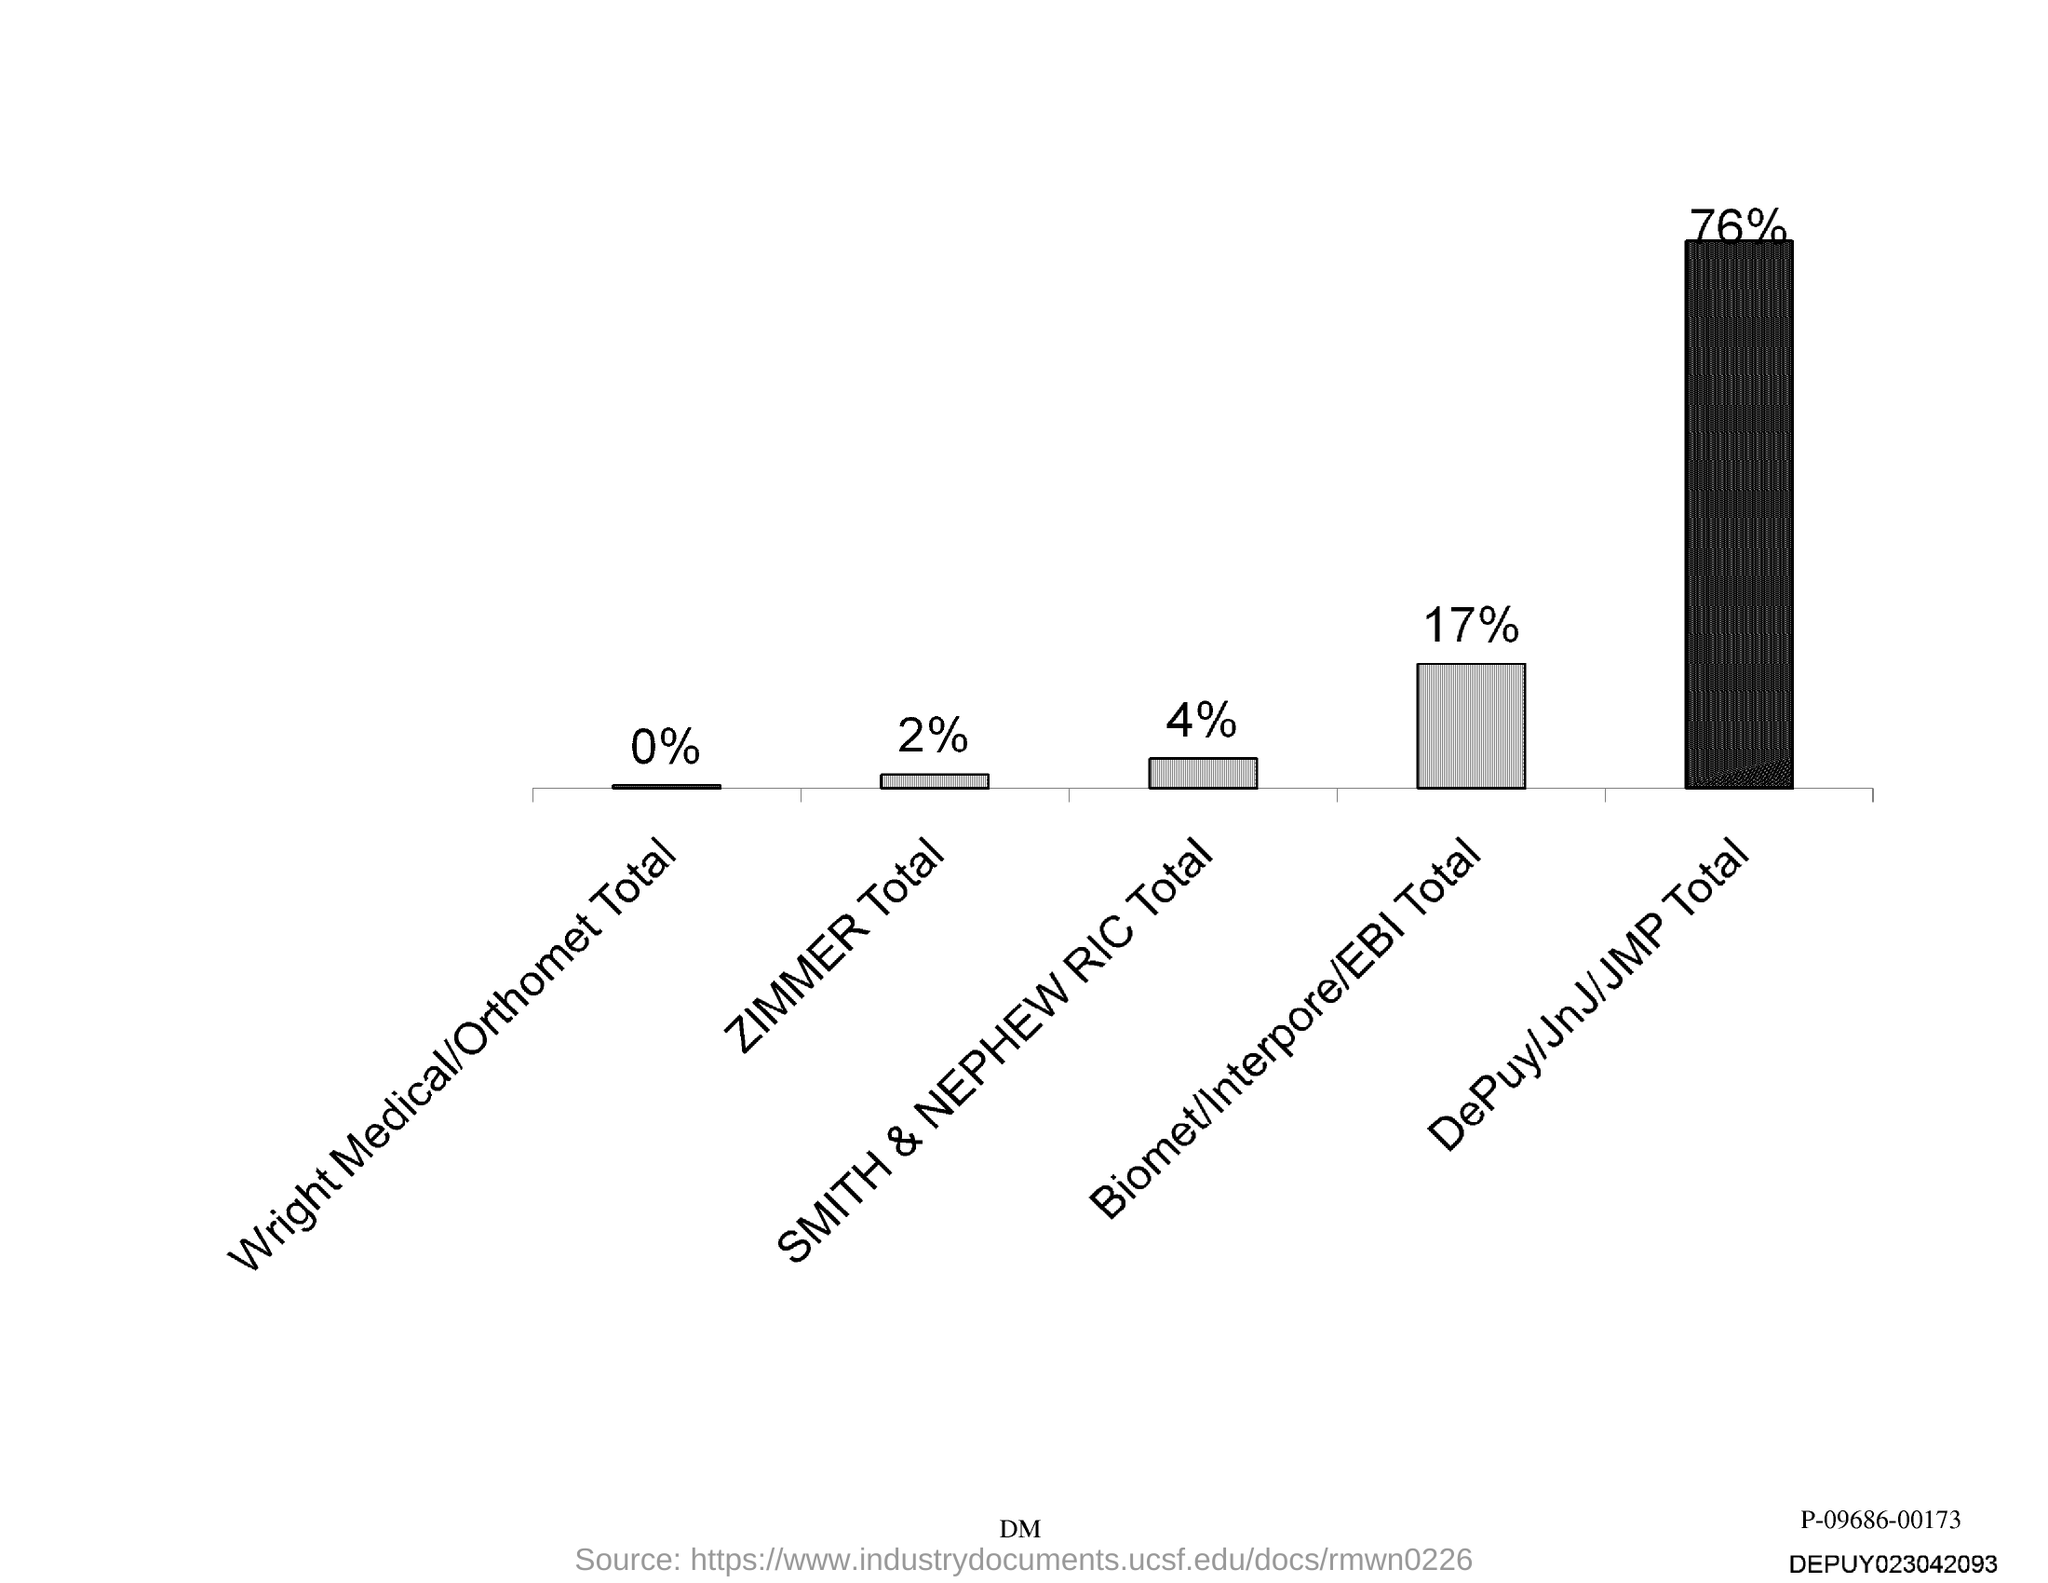List a handful of essential elements in this visual. Smith & Nephew RIC has a current percentage of 4%. Zimmer holds a mere 2% of its total assets in liquid form. The group with the lowest percentage is Wright Medical/Orthomet Total Knee. The category of Biomet/Interpore/EBI received 17% of the total votes. The highest percentage is for DePuy/JnJ/JMP. 